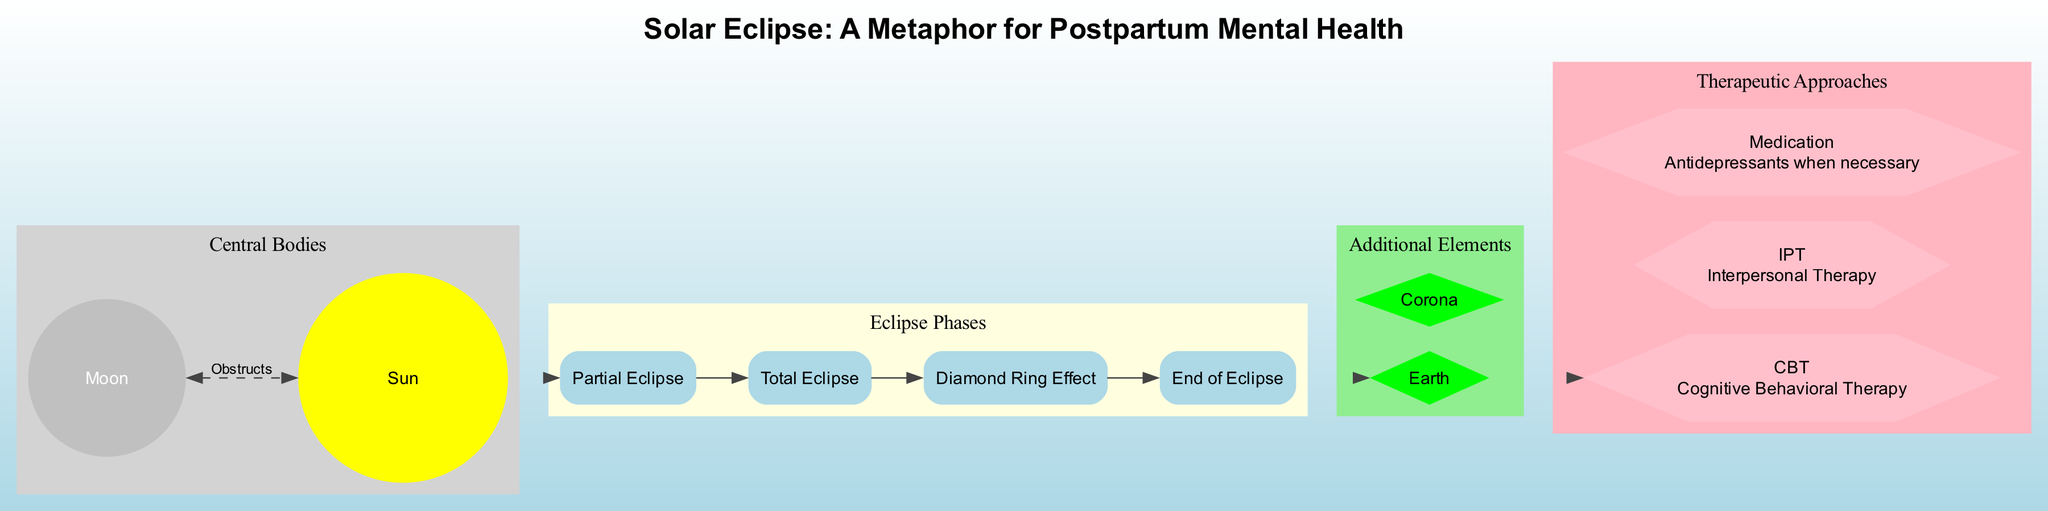What does the Sun represent in the diagram? The Sun symbolizes the mother's core self, which is explicitly stated in the diagram's description.
Answer: Mother's core self What is the relationship between the Moon and the Sun? The Moon, which represents postpartum depression/anxiety, obstructs the Sun, indicating that it temporarily covers or impacts the mother's core self.
Answer: Obstructs How many phases are represented in the diagram? There are four phases listed in the diagram: Partial Eclipse, Total Eclipse, Diamond Ring Effect, and End of Eclipse. This can be counted from the phases section of the diagram.
Answer: Four What does the Diamond Ring Effect signify? The Diamond Ring Effect represents the first signs of recovery, and this interpretation is directly taken from the diagram's description of this phase.
Answer: First signs of recovery Which therapeutic approach is indicated as "Antidepressants when necessary"? The therapeutic approach that corresponds to "Antidepressants when necessary" is labeled as Medication in the diagram.
Answer: Medication What does the Corona illustrate in the context of the diagram? The Corona represents the inner strength that is revealed during the struggle with postpartum mental health issues, according to the diagram's description.
Answer: Inner strength revealed during struggle What phase follows Total Eclipse? The phase that follows the Total Eclipse is the Diamond Ring Effect, as per the sequential order presented in the phases section.
Answer: Diamond Ring Effect Which node represents the mother's support system? The node that represents the mother's support system is labeled as Earth, which is clearly described in the additional elements section of the diagram.
Answer: Earth How does the diagram use the solar eclipse metaphorically? The diagram uses the solar eclipse to symbolize the temporary nature of postpartum depression and anxiety, indicating that symptoms will recede just like the eclipse.
Answer: Temporary nature of postpartum depression and anxiety 